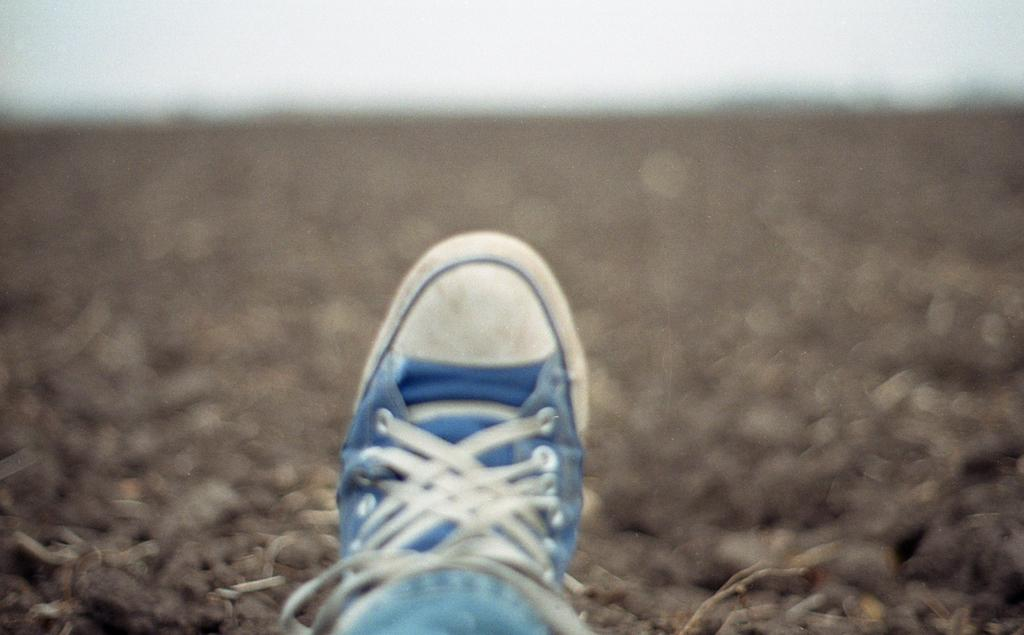What part of the human body is visible in the image? There is a human leg visible in the image. What type of clothing is the person wearing on their leg? The person is wearing a trouser. What type of footwear is the person wearing? The person is wearing a shoe. What type of ground is visible in the image? The ground appears to be sand. Can you see a flock of wrens flying in the image? There are no birds, including wrens, visible in the image. 